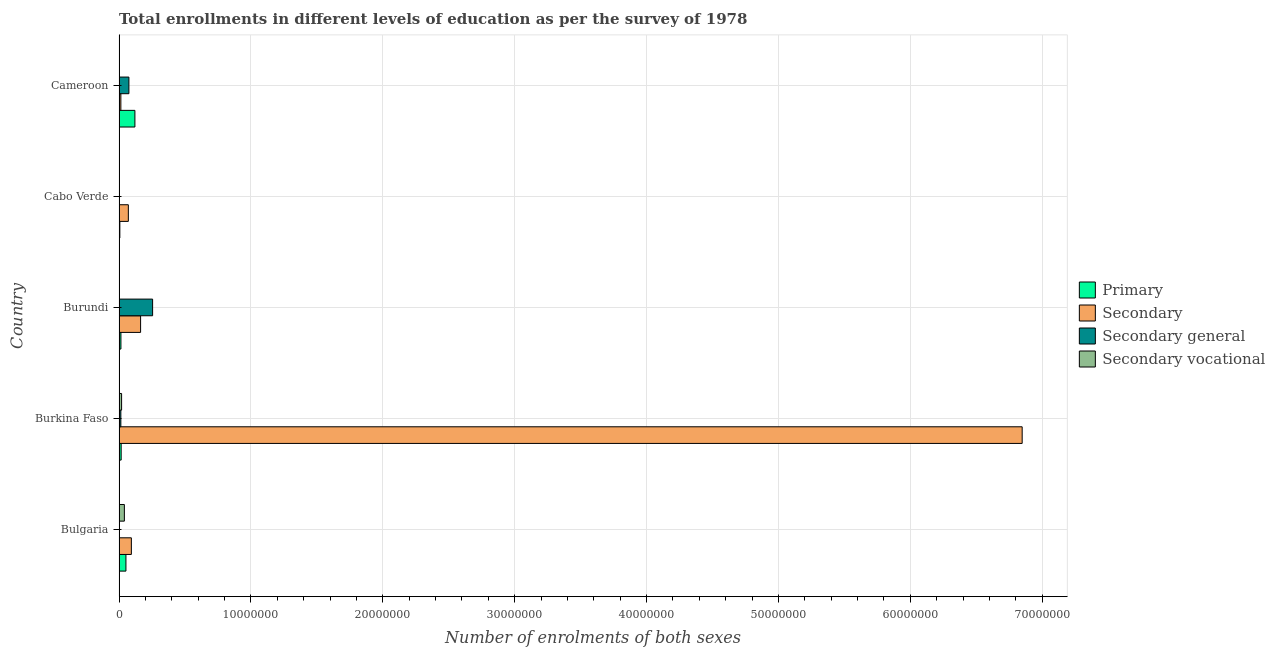How many different coloured bars are there?
Provide a short and direct response. 4. Are the number of bars per tick equal to the number of legend labels?
Make the answer very short. Yes. What is the label of the 4th group of bars from the top?
Your answer should be compact. Burkina Faso. In how many cases, is the number of bars for a given country not equal to the number of legend labels?
Ensure brevity in your answer.  0. What is the number of enrolments in secondary vocational education in Bulgaria?
Keep it short and to the point. 4.04e+05. Across all countries, what is the maximum number of enrolments in secondary general education?
Give a very brief answer. 2.54e+06. Across all countries, what is the minimum number of enrolments in secondary education?
Give a very brief answer. 1.37e+05. In which country was the number of enrolments in secondary vocational education maximum?
Give a very brief answer. Bulgaria. In which country was the number of enrolments in primary education minimum?
Your answer should be compact. Cabo Verde. What is the total number of enrolments in primary education in the graph?
Your answer should be very brief. 2.09e+06. What is the difference between the number of enrolments in secondary vocational education in Bulgaria and that in Burkina Faso?
Keep it short and to the point. 2.12e+05. What is the difference between the number of enrolments in primary education in Burundi and the number of enrolments in secondary education in Burkina Faso?
Make the answer very short. -6.83e+07. What is the average number of enrolments in secondary vocational education per country?
Make the answer very short. 1.31e+05. What is the difference between the number of enrolments in secondary general education and number of enrolments in primary education in Burkina Faso?
Provide a succinct answer. -2.44e+04. What is the ratio of the number of enrolments in secondary education in Burkina Faso to that in Cabo Verde?
Give a very brief answer. 97.24. Is the number of enrolments in secondary general education in Bulgaria less than that in Cabo Verde?
Your answer should be compact. Yes. Is the difference between the number of enrolments in secondary education in Burkina Faso and Cabo Verde greater than the difference between the number of enrolments in primary education in Burkina Faso and Cabo Verde?
Give a very brief answer. Yes. What is the difference between the highest and the second highest number of enrolments in secondary education?
Give a very brief answer. 6.69e+07. What is the difference between the highest and the lowest number of enrolments in primary education?
Make the answer very short. 1.14e+06. Is it the case that in every country, the sum of the number of enrolments in primary education and number of enrolments in secondary general education is greater than the sum of number of enrolments in secondary vocational education and number of enrolments in secondary education?
Offer a terse response. No. What does the 3rd bar from the top in Cameroon represents?
Give a very brief answer. Secondary. What does the 1st bar from the bottom in Bulgaria represents?
Your answer should be very brief. Primary. Are all the bars in the graph horizontal?
Offer a very short reply. Yes. Does the graph contain grids?
Offer a terse response. Yes. Where does the legend appear in the graph?
Offer a terse response. Center right. What is the title of the graph?
Keep it short and to the point. Total enrollments in different levels of education as per the survey of 1978. Does "Permission" appear as one of the legend labels in the graph?
Make the answer very short. No. What is the label or title of the X-axis?
Give a very brief answer. Number of enrolments of both sexes. What is the Number of enrolments of both sexes in Primary in Bulgaria?
Provide a succinct answer. 5.23e+05. What is the Number of enrolments of both sexes in Secondary in Bulgaria?
Your response must be concise. 9.33e+05. What is the Number of enrolments of both sexes in Secondary general in Bulgaria?
Offer a very short reply. 2051. What is the Number of enrolments of both sexes in Secondary vocational in Bulgaria?
Your answer should be compact. 4.04e+05. What is the Number of enrolments of both sexes in Primary in Burkina Faso?
Your answer should be very brief. 1.60e+05. What is the Number of enrolments of both sexes in Secondary in Burkina Faso?
Your response must be concise. 6.85e+07. What is the Number of enrolments of both sexes in Secondary general in Burkina Faso?
Give a very brief answer. 1.36e+05. What is the Number of enrolments of both sexes of Secondary vocational in Burkina Faso?
Your answer should be compact. 1.92e+05. What is the Number of enrolments of both sexes of Primary in Burundi?
Give a very brief answer. 1.42e+05. What is the Number of enrolments of both sexes of Secondary in Burundi?
Offer a very short reply. 1.63e+06. What is the Number of enrolments of both sexes of Secondary general in Burundi?
Keep it short and to the point. 2.54e+06. What is the Number of enrolments of both sexes in Secondary vocational in Burundi?
Make the answer very short. 9432. What is the Number of enrolments of both sexes of Primary in Cabo Verde?
Give a very brief answer. 5.95e+04. What is the Number of enrolments of both sexes in Secondary in Cabo Verde?
Keep it short and to the point. 7.04e+05. What is the Number of enrolments of both sexes of Secondary general in Cabo Verde?
Make the answer very short. 2.75e+04. What is the Number of enrolments of both sexes in Secondary vocational in Cabo Verde?
Provide a succinct answer. 2.99e+04. What is the Number of enrolments of both sexes of Primary in Cameroon?
Your answer should be compact. 1.20e+06. What is the Number of enrolments of both sexes of Secondary in Cameroon?
Your answer should be very brief. 1.37e+05. What is the Number of enrolments of both sexes of Secondary general in Cameroon?
Ensure brevity in your answer.  7.47e+05. What is the Number of enrolments of both sexes in Secondary vocational in Cameroon?
Make the answer very short. 2.18e+04. Across all countries, what is the maximum Number of enrolments of both sexes of Primary?
Ensure brevity in your answer.  1.20e+06. Across all countries, what is the maximum Number of enrolments of both sexes in Secondary?
Ensure brevity in your answer.  6.85e+07. Across all countries, what is the maximum Number of enrolments of both sexes of Secondary general?
Offer a very short reply. 2.54e+06. Across all countries, what is the maximum Number of enrolments of both sexes of Secondary vocational?
Give a very brief answer. 4.04e+05. Across all countries, what is the minimum Number of enrolments of both sexes in Primary?
Your answer should be compact. 5.95e+04. Across all countries, what is the minimum Number of enrolments of both sexes in Secondary?
Your answer should be compact. 1.37e+05. Across all countries, what is the minimum Number of enrolments of both sexes of Secondary general?
Provide a succinct answer. 2051. Across all countries, what is the minimum Number of enrolments of both sexes of Secondary vocational?
Offer a terse response. 9432. What is the total Number of enrolments of both sexes in Primary in the graph?
Ensure brevity in your answer.  2.09e+06. What is the total Number of enrolments of both sexes of Secondary in the graph?
Make the answer very short. 7.19e+07. What is the total Number of enrolments of both sexes of Secondary general in the graph?
Your answer should be compact. 3.46e+06. What is the total Number of enrolments of both sexes of Secondary vocational in the graph?
Offer a terse response. 6.57e+05. What is the difference between the Number of enrolments of both sexes in Primary in Bulgaria and that in Burkina Faso?
Provide a short and direct response. 3.63e+05. What is the difference between the Number of enrolments of both sexes in Secondary in Bulgaria and that in Burkina Faso?
Your response must be concise. -6.76e+07. What is the difference between the Number of enrolments of both sexes in Secondary general in Bulgaria and that in Burkina Faso?
Keep it short and to the point. -1.33e+05. What is the difference between the Number of enrolments of both sexes of Secondary vocational in Bulgaria and that in Burkina Faso?
Your response must be concise. 2.12e+05. What is the difference between the Number of enrolments of both sexes in Primary in Bulgaria and that in Burundi?
Provide a succinct answer. 3.80e+05. What is the difference between the Number of enrolments of both sexes of Secondary in Bulgaria and that in Burundi?
Provide a succinct answer. -7.00e+05. What is the difference between the Number of enrolments of both sexes of Secondary general in Bulgaria and that in Burundi?
Your answer should be compact. -2.54e+06. What is the difference between the Number of enrolments of both sexes of Secondary vocational in Bulgaria and that in Burundi?
Offer a terse response. 3.95e+05. What is the difference between the Number of enrolments of both sexes in Primary in Bulgaria and that in Cabo Verde?
Provide a short and direct response. 4.63e+05. What is the difference between the Number of enrolments of both sexes in Secondary in Bulgaria and that in Cabo Verde?
Offer a terse response. 2.29e+05. What is the difference between the Number of enrolments of both sexes in Secondary general in Bulgaria and that in Cabo Verde?
Keep it short and to the point. -2.54e+04. What is the difference between the Number of enrolments of both sexes of Secondary vocational in Bulgaria and that in Cabo Verde?
Give a very brief answer. 3.74e+05. What is the difference between the Number of enrolments of both sexes in Primary in Bulgaria and that in Cameroon?
Provide a short and direct response. -6.80e+05. What is the difference between the Number of enrolments of both sexes in Secondary in Bulgaria and that in Cameroon?
Your answer should be compact. 7.97e+05. What is the difference between the Number of enrolments of both sexes in Secondary general in Bulgaria and that in Cameroon?
Your answer should be compact. -7.45e+05. What is the difference between the Number of enrolments of both sexes in Secondary vocational in Bulgaria and that in Cameroon?
Provide a succinct answer. 3.82e+05. What is the difference between the Number of enrolments of both sexes of Primary in Burkina Faso and that in Burundi?
Make the answer very short. 1.77e+04. What is the difference between the Number of enrolments of both sexes in Secondary in Burkina Faso and that in Burundi?
Provide a short and direct response. 6.69e+07. What is the difference between the Number of enrolments of both sexes of Secondary general in Burkina Faso and that in Burundi?
Your answer should be very brief. -2.41e+06. What is the difference between the Number of enrolments of both sexes of Secondary vocational in Burkina Faso and that in Burundi?
Provide a succinct answer. 1.83e+05. What is the difference between the Number of enrolments of both sexes of Primary in Burkina Faso and that in Cabo Verde?
Your answer should be very brief. 1.00e+05. What is the difference between the Number of enrolments of both sexes of Secondary in Burkina Faso and that in Cabo Verde?
Give a very brief answer. 6.78e+07. What is the difference between the Number of enrolments of both sexes in Secondary general in Burkina Faso and that in Cabo Verde?
Give a very brief answer. 1.08e+05. What is the difference between the Number of enrolments of both sexes of Secondary vocational in Burkina Faso and that in Cabo Verde?
Offer a very short reply. 1.62e+05. What is the difference between the Number of enrolments of both sexes of Primary in Burkina Faso and that in Cameroon?
Your answer should be very brief. -1.04e+06. What is the difference between the Number of enrolments of both sexes of Secondary in Burkina Faso and that in Cameroon?
Keep it short and to the point. 6.84e+07. What is the difference between the Number of enrolments of both sexes of Secondary general in Burkina Faso and that in Cameroon?
Your answer should be compact. -6.12e+05. What is the difference between the Number of enrolments of both sexes in Secondary vocational in Burkina Faso and that in Cameroon?
Provide a short and direct response. 1.71e+05. What is the difference between the Number of enrolments of both sexes of Primary in Burundi and that in Cabo Verde?
Offer a terse response. 8.27e+04. What is the difference between the Number of enrolments of both sexes of Secondary in Burundi and that in Cabo Verde?
Provide a succinct answer. 9.29e+05. What is the difference between the Number of enrolments of both sexes of Secondary general in Burundi and that in Cabo Verde?
Offer a very short reply. 2.52e+06. What is the difference between the Number of enrolments of both sexes of Secondary vocational in Burundi and that in Cabo Verde?
Keep it short and to the point. -2.05e+04. What is the difference between the Number of enrolments of both sexes of Primary in Burundi and that in Cameroon?
Your answer should be compact. -1.06e+06. What is the difference between the Number of enrolments of both sexes of Secondary in Burundi and that in Cameroon?
Your answer should be compact. 1.50e+06. What is the difference between the Number of enrolments of both sexes of Secondary general in Burundi and that in Cameroon?
Provide a succinct answer. 1.80e+06. What is the difference between the Number of enrolments of both sexes of Secondary vocational in Burundi and that in Cameroon?
Offer a terse response. -1.24e+04. What is the difference between the Number of enrolments of both sexes of Primary in Cabo Verde and that in Cameroon?
Your answer should be compact. -1.14e+06. What is the difference between the Number of enrolments of both sexes of Secondary in Cabo Verde and that in Cameroon?
Make the answer very short. 5.68e+05. What is the difference between the Number of enrolments of both sexes in Secondary general in Cabo Verde and that in Cameroon?
Give a very brief answer. -7.20e+05. What is the difference between the Number of enrolments of both sexes in Secondary vocational in Cabo Verde and that in Cameroon?
Your answer should be compact. 8082. What is the difference between the Number of enrolments of both sexes in Primary in Bulgaria and the Number of enrolments of both sexes in Secondary in Burkina Faso?
Provide a succinct answer. -6.80e+07. What is the difference between the Number of enrolments of both sexes in Primary in Bulgaria and the Number of enrolments of both sexes in Secondary general in Burkina Faso?
Make the answer very short. 3.87e+05. What is the difference between the Number of enrolments of both sexes of Primary in Bulgaria and the Number of enrolments of both sexes of Secondary vocational in Burkina Faso?
Your response must be concise. 3.30e+05. What is the difference between the Number of enrolments of both sexes in Secondary in Bulgaria and the Number of enrolments of both sexes in Secondary general in Burkina Faso?
Your response must be concise. 7.98e+05. What is the difference between the Number of enrolments of both sexes in Secondary in Bulgaria and the Number of enrolments of both sexes in Secondary vocational in Burkina Faso?
Keep it short and to the point. 7.41e+05. What is the difference between the Number of enrolments of both sexes in Secondary general in Bulgaria and the Number of enrolments of both sexes in Secondary vocational in Burkina Faso?
Offer a terse response. -1.90e+05. What is the difference between the Number of enrolments of both sexes in Primary in Bulgaria and the Number of enrolments of both sexes in Secondary in Burundi?
Make the answer very short. -1.11e+06. What is the difference between the Number of enrolments of both sexes in Primary in Bulgaria and the Number of enrolments of both sexes in Secondary general in Burundi?
Ensure brevity in your answer.  -2.02e+06. What is the difference between the Number of enrolments of both sexes in Primary in Bulgaria and the Number of enrolments of both sexes in Secondary vocational in Burundi?
Your response must be concise. 5.13e+05. What is the difference between the Number of enrolments of both sexes in Secondary in Bulgaria and the Number of enrolments of both sexes in Secondary general in Burundi?
Your answer should be compact. -1.61e+06. What is the difference between the Number of enrolments of both sexes in Secondary in Bulgaria and the Number of enrolments of both sexes in Secondary vocational in Burundi?
Your answer should be compact. 9.24e+05. What is the difference between the Number of enrolments of both sexes of Secondary general in Bulgaria and the Number of enrolments of both sexes of Secondary vocational in Burundi?
Keep it short and to the point. -7381. What is the difference between the Number of enrolments of both sexes of Primary in Bulgaria and the Number of enrolments of both sexes of Secondary in Cabo Verde?
Your response must be concise. -1.82e+05. What is the difference between the Number of enrolments of both sexes in Primary in Bulgaria and the Number of enrolments of both sexes in Secondary general in Cabo Verde?
Ensure brevity in your answer.  4.95e+05. What is the difference between the Number of enrolments of both sexes of Primary in Bulgaria and the Number of enrolments of both sexes of Secondary vocational in Cabo Verde?
Your answer should be very brief. 4.93e+05. What is the difference between the Number of enrolments of both sexes in Secondary in Bulgaria and the Number of enrolments of both sexes in Secondary general in Cabo Verde?
Keep it short and to the point. 9.06e+05. What is the difference between the Number of enrolments of both sexes in Secondary in Bulgaria and the Number of enrolments of both sexes in Secondary vocational in Cabo Verde?
Provide a short and direct response. 9.03e+05. What is the difference between the Number of enrolments of both sexes in Secondary general in Bulgaria and the Number of enrolments of both sexes in Secondary vocational in Cabo Verde?
Give a very brief answer. -2.78e+04. What is the difference between the Number of enrolments of both sexes of Primary in Bulgaria and the Number of enrolments of both sexes of Secondary in Cameroon?
Provide a short and direct response. 3.86e+05. What is the difference between the Number of enrolments of both sexes in Primary in Bulgaria and the Number of enrolments of both sexes in Secondary general in Cameroon?
Ensure brevity in your answer.  -2.24e+05. What is the difference between the Number of enrolments of both sexes of Primary in Bulgaria and the Number of enrolments of both sexes of Secondary vocational in Cameroon?
Give a very brief answer. 5.01e+05. What is the difference between the Number of enrolments of both sexes of Secondary in Bulgaria and the Number of enrolments of both sexes of Secondary general in Cameroon?
Provide a succinct answer. 1.86e+05. What is the difference between the Number of enrolments of both sexes in Secondary in Bulgaria and the Number of enrolments of both sexes in Secondary vocational in Cameroon?
Offer a terse response. 9.11e+05. What is the difference between the Number of enrolments of both sexes in Secondary general in Bulgaria and the Number of enrolments of both sexes in Secondary vocational in Cameroon?
Offer a very short reply. -1.98e+04. What is the difference between the Number of enrolments of both sexes in Primary in Burkina Faso and the Number of enrolments of both sexes in Secondary in Burundi?
Give a very brief answer. -1.47e+06. What is the difference between the Number of enrolments of both sexes of Primary in Burkina Faso and the Number of enrolments of both sexes of Secondary general in Burundi?
Offer a terse response. -2.38e+06. What is the difference between the Number of enrolments of both sexes in Primary in Burkina Faso and the Number of enrolments of both sexes in Secondary vocational in Burundi?
Provide a short and direct response. 1.51e+05. What is the difference between the Number of enrolments of both sexes of Secondary in Burkina Faso and the Number of enrolments of both sexes of Secondary general in Burundi?
Give a very brief answer. 6.59e+07. What is the difference between the Number of enrolments of both sexes of Secondary in Burkina Faso and the Number of enrolments of both sexes of Secondary vocational in Burundi?
Your answer should be very brief. 6.85e+07. What is the difference between the Number of enrolments of both sexes of Secondary general in Burkina Faso and the Number of enrolments of both sexes of Secondary vocational in Burundi?
Your response must be concise. 1.26e+05. What is the difference between the Number of enrolments of both sexes of Primary in Burkina Faso and the Number of enrolments of both sexes of Secondary in Cabo Verde?
Your response must be concise. -5.44e+05. What is the difference between the Number of enrolments of both sexes of Primary in Burkina Faso and the Number of enrolments of both sexes of Secondary general in Cabo Verde?
Your response must be concise. 1.32e+05. What is the difference between the Number of enrolments of both sexes of Primary in Burkina Faso and the Number of enrolments of both sexes of Secondary vocational in Cabo Verde?
Provide a short and direct response. 1.30e+05. What is the difference between the Number of enrolments of both sexes in Secondary in Burkina Faso and the Number of enrolments of both sexes in Secondary general in Cabo Verde?
Ensure brevity in your answer.  6.85e+07. What is the difference between the Number of enrolments of both sexes in Secondary in Burkina Faso and the Number of enrolments of both sexes in Secondary vocational in Cabo Verde?
Make the answer very short. 6.85e+07. What is the difference between the Number of enrolments of both sexes in Secondary general in Burkina Faso and the Number of enrolments of both sexes in Secondary vocational in Cabo Verde?
Your answer should be compact. 1.06e+05. What is the difference between the Number of enrolments of both sexes of Primary in Burkina Faso and the Number of enrolments of both sexes of Secondary in Cameroon?
Offer a very short reply. 2.33e+04. What is the difference between the Number of enrolments of both sexes in Primary in Burkina Faso and the Number of enrolments of both sexes in Secondary general in Cameroon?
Provide a short and direct response. -5.87e+05. What is the difference between the Number of enrolments of both sexes of Primary in Burkina Faso and the Number of enrolments of both sexes of Secondary vocational in Cameroon?
Provide a short and direct response. 1.38e+05. What is the difference between the Number of enrolments of both sexes of Secondary in Burkina Faso and the Number of enrolments of both sexes of Secondary general in Cameroon?
Offer a terse response. 6.77e+07. What is the difference between the Number of enrolments of both sexes of Secondary in Burkina Faso and the Number of enrolments of both sexes of Secondary vocational in Cameroon?
Ensure brevity in your answer.  6.85e+07. What is the difference between the Number of enrolments of both sexes in Secondary general in Burkina Faso and the Number of enrolments of both sexes in Secondary vocational in Cameroon?
Your response must be concise. 1.14e+05. What is the difference between the Number of enrolments of both sexes of Primary in Burundi and the Number of enrolments of both sexes of Secondary in Cabo Verde?
Offer a terse response. -5.62e+05. What is the difference between the Number of enrolments of both sexes of Primary in Burundi and the Number of enrolments of both sexes of Secondary general in Cabo Verde?
Your answer should be compact. 1.15e+05. What is the difference between the Number of enrolments of both sexes of Primary in Burundi and the Number of enrolments of both sexes of Secondary vocational in Cabo Verde?
Your answer should be compact. 1.12e+05. What is the difference between the Number of enrolments of both sexes of Secondary in Burundi and the Number of enrolments of both sexes of Secondary general in Cabo Verde?
Provide a succinct answer. 1.61e+06. What is the difference between the Number of enrolments of both sexes of Secondary in Burundi and the Number of enrolments of both sexes of Secondary vocational in Cabo Verde?
Your answer should be compact. 1.60e+06. What is the difference between the Number of enrolments of both sexes in Secondary general in Burundi and the Number of enrolments of both sexes in Secondary vocational in Cabo Verde?
Your answer should be compact. 2.51e+06. What is the difference between the Number of enrolments of both sexes of Primary in Burundi and the Number of enrolments of both sexes of Secondary in Cameroon?
Provide a short and direct response. 5592. What is the difference between the Number of enrolments of both sexes in Primary in Burundi and the Number of enrolments of both sexes in Secondary general in Cameroon?
Keep it short and to the point. -6.05e+05. What is the difference between the Number of enrolments of both sexes in Primary in Burundi and the Number of enrolments of both sexes in Secondary vocational in Cameroon?
Offer a very short reply. 1.20e+05. What is the difference between the Number of enrolments of both sexes in Secondary in Burundi and the Number of enrolments of both sexes in Secondary general in Cameroon?
Give a very brief answer. 8.87e+05. What is the difference between the Number of enrolments of both sexes in Secondary in Burundi and the Number of enrolments of both sexes in Secondary vocational in Cameroon?
Provide a succinct answer. 1.61e+06. What is the difference between the Number of enrolments of both sexes in Secondary general in Burundi and the Number of enrolments of both sexes in Secondary vocational in Cameroon?
Provide a short and direct response. 2.52e+06. What is the difference between the Number of enrolments of both sexes in Primary in Cabo Verde and the Number of enrolments of both sexes in Secondary in Cameroon?
Your answer should be very brief. -7.71e+04. What is the difference between the Number of enrolments of both sexes of Primary in Cabo Verde and the Number of enrolments of both sexes of Secondary general in Cameroon?
Your answer should be very brief. -6.88e+05. What is the difference between the Number of enrolments of both sexes in Primary in Cabo Verde and the Number of enrolments of both sexes in Secondary vocational in Cameroon?
Your answer should be very brief. 3.77e+04. What is the difference between the Number of enrolments of both sexes of Secondary in Cabo Verde and the Number of enrolments of both sexes of Secondary general in Cameroon?
Give a very brief answer. -4.28e+04. What is the difference between the Number of enrolments of both sexes in Secondary in Cabo Verde and the Number of enrolments of both sexes in Secondary vocational in Cameroon?
Ensure brevity in your answer.  6.83e+05. What is the difference between the Number of enrolments of both sexes of Secondary general in Cabo Verde and the Number of enrolments of both sexes of Secondary vocational in Cameroon?
Make the answer very short. 5685. What is the average Number of enrolments of both sexes in Primary per country?
Ensure brevity in your answer.  4.17e+05. What is the average Number of enrolments of both sexes in Secondary per country?
Your answer should be compact. 1.44e+07. What is the average Number of enrolments of both sexes in Secondary general per country?
Your answer should be very brief. 6.91e+05. What is the average Number of enrolments of both sexes of Secondary vocational per country?
Your response must be concise. 1.31e+05. What is the difference between the Number of enrolments of both sexes of Primary and Number of enrolments of both sexes of Secondary in Bulgaria?
Provide a short and direct response. -4.11e+05. What is the difference between the Number of enrolments of both sexes in Primary and Number of enrolments of both sexes in Secondary general in Bulgaria?
Ensure brevity in your answer.  5.21e+05. What is the difference between the Number of enrolments of both sexes of Primary and Number of enrolments of both sexes of Secondary vocational in Bulgaria?
Provide a succinct answer. 1.19e+05. What is the difference between the Number of enrolments of both sexes of Secondary and Number of enrolments of both sexes of Secondary general in Bulgaria?
Offer a very short reply. 9.31e+05. What is the difference between the Number of enrolments of both sexes of Secondary and Number of enrolments of both sexes of Secondary vocational in Bulgaria?
Your response must be concise. 5.29e+05. What is the difference between the Number of enrolments of both sexes in Secondary general and Number of enrolments of both sexes in Secondary vocational in Bulgaria?
Ensure brevity in your answer.  -4.02e+05. What is the difference between the Number of enrolments of both sexes of Primary and Number of enrolments of both sexes of Secondary in Burkina Faso?
Offer a terse response. -6.83e+07. What is the difference between the Number of enrolments of both sexes of Primary and Number of enrolments of both sexes of Secondary general in Burkina Faso?
Your answer should be compact. 2.44e+04. What is the difference between the Number of enrolments of both sexes of Primary and Number of enrolments of both sexes of Secondary vocational in Burkina Faso?
Your answer should be compact. -3.24e+04. What is the difference between the Number of enrolments of both sexes in Secondary and Number of enrolments of both sexes in Secondary general in Burkina Faso?
Make the answer very short. 6.84e+07. What is the difference between the Number of enrolments of both sexes of Secondary and Number of enrolments of both sexes of Secondary vocational in Burkina Faso?
Give a very brief answer. 6.83e+07. What is the difference between the Number of enrolments of both sexes in Secondary general and Number of enrolments of both sexes in Secondary vocational in Burkina Faso?
Make the answer very short. -5.68e+04. What is the difference between the Number of enrolments of both sexes in Primary and Number of enrolments of both sexes in Secondary in Burundi?
Ensure brevity in your answer.  -1.49e+06. What is the difference between the Number of enrolments of both sexes of Primary and Number of enrolments of both sexes of Secondary general in Burundi?
Give a very brief answer. -2.40e+06. What is the difference between the Number of enrolments of both sexes in Primary and Number of enrolments of both sexes in Secondary vocational in Burundi?
Ensure brevity in your answer.  1.33e+05. What is the difference between the Number of enrolments of both sexes of Secondary and Number of enrolments of both sexes of Secondary general in Burundi?
Ensure brevity in your answer.  -9.11e+05. What is the difference between the Number of enrolments of both sexes in Secondary and Number of enrolments of both sexes in Secondary vocational in Burundi?
Your answer should be compact. 1.62e+06. What is the difference between the Number of enrolments of both sexes of Secondary general and Number of enrolments of both sexes of Secondary vocational in Burundi?
Provide a short and direct response. 2.53e+06. What is the difference between the Number of enrolments of both sexes in Primary and Number of enrolments of both sexes in Secondary in Cabo Verde?
Keep it short and to the point. -6.45e+05. What is the difference between the Number of enrolments of both sexes of Primary and Number of enrolments of both sexes of Secondary general in Cabo Verde?
Keep it short and to the point. 3.20e+04. What is the difference between the Number of enrolments of both sexes in Primary and Number of enrolments of both sexes in Secondary vocational in Cabo Verde?
Offer a very short reply. 2.96e+04. What is the difference between the Number of enrolments of both sexes of Secondary and Number of enrolments of both sexes of Secondary general in Cabo Verde?
Make the answer very short. 6.77e+05. What is the difference between the Number of enrolments of both sexes in Secondary and Number of enrolments of both sexes in Secondary vocational in Cabo Verde?
Offer a terse response. 6.74e+05. What is the difference between the Number of enrolments of both sexes in Secondary general and Number of enrolments of both sexes in Secondary vocational in Cabo Verde?
Your answer should be compact. -2397. What is the difference between the Number of enrolments of both sexes of Primary and Number of enrolments of both sexes of Secondary in Cameroon?
Your response must be concise. 1.07e+06. What is the difference between the Number of enrolments of both sexes in Primary and Number of enrolments of both sexes in Secondary general in Cameroon?
Provide a short and direct response. 4.56e+05. What is the difference between the Number of enrolments of both sexes of Primary and Number of enrolments of both sexes of Secondary vocational in Cameroon?
Provide a succinct answer. 1.18e+06. What is the difference between the Number of enrolments of both sexes in Secondary and Number of enrolments of both sexes in Secondary general in Cameroon?
Your answer should be very brief. -6.10e+05. What is the difference between the Number of enrolments of both sexes of Secondary and Number of enrolments of both sexes of Secondary vocational in Cameroon?
Provide a short and direct response. 1.15e+05. What is the difference between the Number of enrolments of both sexes of Secondary general and Number of enrolments of both sexes of Secondary vocational in Cameroon?
Offer a very short reply. 7.25e+05. What is the ratio of the Number of enrolments of both sexes in Primary in Bulgaria to that in Burkina Faso?
Your response must be concise. 3.27. What is the ratio of the Number of enrolments of both sexes in Secondary in Bulgaria to that in Burkina Faso?
Keep it short and to the point. 0.01. What is the ratio of the Number of enrolments of both sexes of Secondary general in Bulgaria to that in Burkina Faso?
Give a very brief answer. 0.02. What is the ratio of the Number of enrolments of both sexes in Secondary vocational in Bulgaria to that in Burkina Faso?
Your response must be concise. 2.1. What is the ratio of the Number of enrolments of both sexes in Primary in Bulgaria to that in Burundi?
Give a very brief answer. 3.67. What is the ratio of the Number of enrolments of both sexes of Secondary in Bulgaria to that in Burundi?
Provide a short and direct response. 0.57. What is the ratio of the Number of enrolments of both sexes in Secondary general in Bulgaria to that in Burundi?
Provide a short and direct response. 0. What is the ratio of the Number of enrolments of both sexes in Secondary vocational in Bulgaria to that in Burundi?
Your response must be concise. 42.83. What is the ratio of the Number of enrolments of both sexes in Primary in Bulgaria to that in Cabo Verde?
Make the answer very short. 8.78. What is the ratio of the Number of enrolments of both sexes of Secondary in Bulgaria to that in Cabo Verde?
Your answer should be compact. 1.32. What is the ratio of the Number of enrolments of both sexes of Secondary general in Bulgaria to that in Cabo Verde?
Your answer should be very brief. 0.07. What is the ratio of the Number of enrolments of both sexes of Secondary vocational in Bulgaria to that in Cabo Verde?
Give a very brief answer. 13.51. What is the ratio of the Number of enrolments of both sexes of Primary in Bulgaria to that in Cameroon?
Offer a very short reply. 0.43. What is the ratio of the Number of enrolments of both sexes in Secondary in Bulgaria to that in Cameroon?
Make the answer very short. 6.83. What is the ratio of the Number of enrolments of both sexes of Secondary general in Bulgaria to that in Cameroon?
Your response must be concise. 0. What is the ratio of the Number of enrolments of both sexes of Secondary vocational in Bulgaria to that in Cameroon?
Your answer should be compact. 18.52. What is the ratio of the Number of enrolments of both sexes of Primary in Burkina Faso to that in Burundi?
Your answer should be compact. 1.12. What is the ratio of the Number of enrolments of both sexes in Secondary in Burkina Faso to that in Burundi?
Make the answer very short. 41.92. What is the ratio of the Number of enrolments of both sexes in Secondary general in Burkina Faso to that in Burundi?
Give a very brief answer. 0.05. What is the ratio of the Number of enrolments of both sexes of Secondary vocational in Burkina Faso to that in Burundi?
Offer a very short reply. 20.39. What is the ratio of the Number of enrolments of both sexes in Primary in Burkina Faso to that in Cabo Verde?
Your answer should be compact. 2.69. What is the ratio of the Number of enrolments of both sexes in Secondary in Burkina Faso to that in Cabo Verde?
Provide a short and direct response. 97.24. What is the ratio of the Number of enrolments of both sexes of Secondary general in Burkina Faso to that in Cabo Verde?
Provide a short and direct response. 4.93. What is the ratio of the Number of enrolments of both sexes of Secondary vocational in Burkina Faso to that in Cabo Verde?
Offer a terse response. 6.43. What is the ratio of the Number of enrolments of both sexes of Primary in Burkina Faso to that in Cameroon?
Keep it short and to the point. 0.13. What is the ratio of the Number of enrolments of both sexes in Secondary in Burkina Faso to that in Cameroon?
Provide a succinct answer. 501.22. What is the ratio of the Number of enrolments of both sexes of Secondary general in Burkina Faso to that in Cameroon?
Offer a terse response. 0.18. What is the ratio of the Number of enrolments of both sexes in Secondary vocational in Burkina Faso to that in Cameroon?
Offer a terse response. 8.82. What is the ratio of the Number of enrolments of both sexes in Primary in Burundi to that in Cabo Verde?
Provide a succinct answer. 2.39. What is the ratio of the Number of enrolments of both sexes of Secondary in Burundi to that in Cabo Verde?
Offer a terse response. 2.32. What is the ratio of the Number of enrolments of both sexes in Secondary general in Burundi to that in Cabo Verde?
Offer a terse response. 92.53. What is the ratio of the Number of enrolments of both sexes in Secondary vocational in Burundi to that in Cabo Verde?
Offer a terse response. 0.32. What is the ratio of the Number of enrolments of both sexes in Primary in Burundi to that in Cameroon?
Give a very brief answer. 0.12. What is the ratio of the Number of enrolments of both sexes in Secondary in Burundi to that in Cameroon?
Provide a succinct answer. 11.96. What is the ratio of the Number of enrolments of both sexes of Secondary general in Burundi to that in Cameroon?
Keep it short and to the point. 3.41. What is the ratio of the Number of enrolments of both sexes of Secondary vocational in Burundi to that in Cameroon?
Your answer should be very brief. 0.43. What is the ratio of the Number of enrolments of both sexes in Primary in Cabo Verde to that in Cameroon?
Keep it short and to the point. 0.05. What is the ratio of the Number of enrolments of both sexes in Secondary in Cabo Verde to that in Cameroon?
Your response must be concise. 5.15. What is the ratio of the Number of enrolments of both sexes of Secondary general in Cabo Verde to that in Cameroon?
Offer a terse response. 0.04. What is the ratio of the Number of enrolments of both sexes in Secondary vocational in Cabo Verde to that in Cameroon?
Give a very brief answer. 1.37. What is the difference between the highest and the second highest Number of enrolments of both sexes of Primary?
Ensure brevity in your answer.  6.80e+05. What is the difference between the highest and the second highest Number of enrolments of both sexes of Secondary?
Offer a terse response. 6.69e+07. What is the difference between the highest and the second highest Number of enrolments of both sexes of Secondary general?
Ensure brevity in your answer.  1.80e+06. What is the difference between the highest and the second highest Number of enrolments of both sexes in Secondary vocational?
Keep it short and to the point. 2.12e+05. What is the difference between the highest and the lowest Number of enrolments of both sexes in Primary?
Give a very brief answer. 1.14e+06. What is the difference between the highest and the lowest Number of enrolments of both sexes in Secondary?
Provide a succinct answer. 6.84e+07. What is the difference between the highest and the lowest Number of enrolments of both sexes in Secondary general?
Your response must be concise. 2.54e+06. What is the difference between the highest and the lowest Number of enrolments of both sexes of Secondary vocational?
Keep it short and to the point. 3.95e+05. 